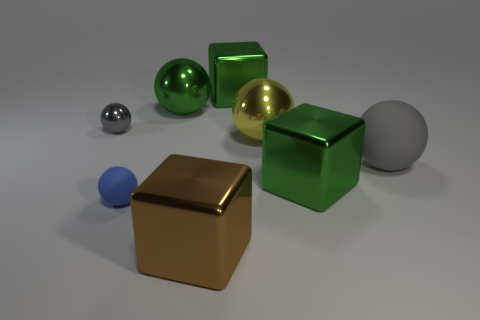Subtract 2 balls. How many balls are left? 3 Subtract all yellow balls. How many balls are left? 4 Subtract all blue balls. How many balls are left? 4 Add 1 yellow metallic things. How many objects exist? 9 Subtract all cyan spheres. Subtract all brown blocks. How many spheres are left? 5 Subtract all spheres. How many objects are left? 3 Add 2 big gray matte cylinders. How many big gray matte cylinders exist? 2 Subtract 0 cyan spheres. How many objects are left? 8 Subtract all gray metal objects. Subtract all tiny blue spheres. How many objects are left? 6 Add 3 small blue rubber spheres. How many small blue rubber spheres are left? 4 